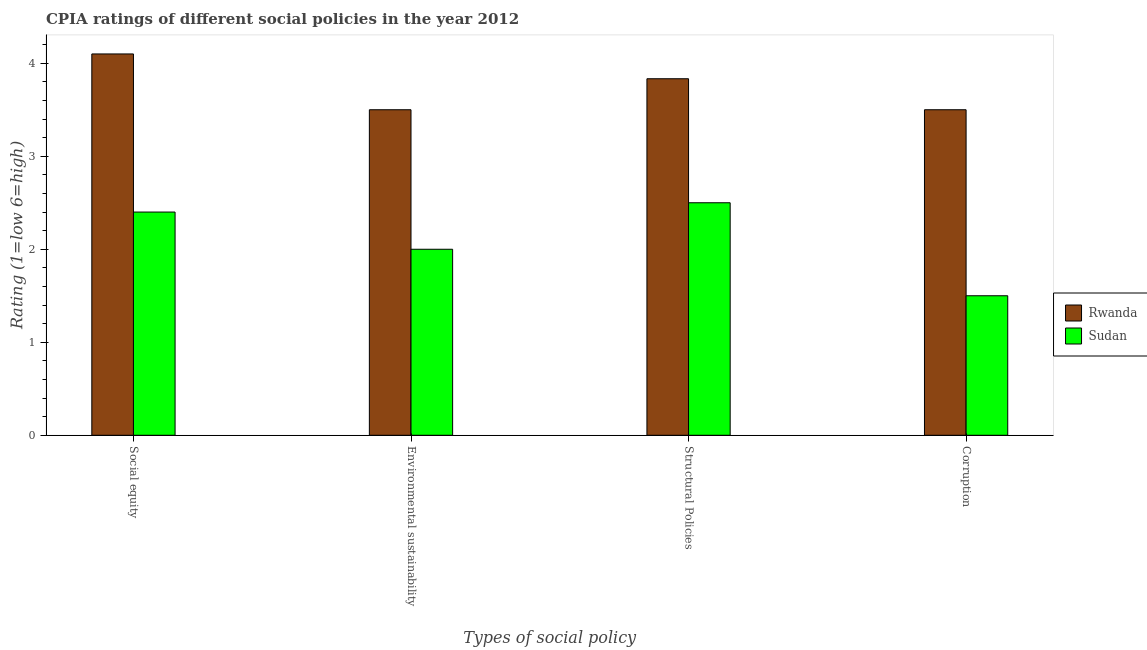How many groups of bars are there?
Offer a terse response. 4. Are the number of bars on each tick of the X-axis equal?
Offer a very short reply. Yes. How many bars are there on the 4th tick from the right?
Keep it short and to the point. 2. What is the label of the 2nd group of bars from the left?
Give a very brief answer. Environmental sustainability. What is the cpia rating of structural policies in Rwanda?
Your response must be concise. 3.83. Across all countries, what is the maximum cpia rating of environmental sustainability?
Offer a terse response. 3.5. In which country was the cpia rating of corruption maximum?
Offer a terse response. Rwanda. In which country was the cpia rating of structural policies minimum?
Offer a terse response. Sudan. What is the total cpia rating of social equity in the graph?
Your response must be concise. 6.5. What is the difference between the cpia rating of corruption in Rwanda and that in Sudan?
Your answer should be compact. 2. What is the average cpia rating of corruption per country?
Provide a succinct answer. 2.5. What is the difference between the cpia rating of social equity and cpia rating of environmental sustainability in Sudan?
Your response must be concise. 0.4. In how many countries, is the cpia rating of environmental sustainability greater than 0.4 ?
Your answer should be compact. 2. What is the ratio of the cpia rating of structural policies in Rwanda to that in Sudan?
Offer a terse response. 1.53. Is the cpia rating of structural policies in Sudan less than that in Rwanda?
Offer a very short reply. Yes. Is the difference between the cpia rating of structural policies in Sudan and Rwanda greater than the difference between the cpia rating of corruption in Sudan and Rwanda?
Offer a very short reply. Yes. What is the difference between the highest and the second highest cpia rating of social equity?
Make the answer very short. 1.7. What is the difference between the highest and the lowest cpia rating of corruption?
Provide a short and direct response. 2. Is the sum of the cpia rating of structural policies in Sudan and Rwanda greater than the maximum cpia rating of social equity across all countries?
Your answer should be very brief. Yes. Is it the case that in every country, the sum of the cpia rating of environmental sustainability and cpia rating of structural policies is greater than the sum of cpia rating of corruption and cpia rating of social equity?
Keep it short and to the point. No. What does the 2nd bar from the left in Environmental sustainability represents?
Give a very brief answer. Sudan. What does the 1st bar from the right in Social equity represents?
Offer a terse response. Sudan. Is it the case that in every country, the sum of the cpia rating of social equity and cpia rating of environmental sustainability is greater than the cpia rating of structural policies?
Offer a very short reply. Yes. How many bars are there?
Offer a very short reply. 8. How many countries are there in the graph?
Offer a very short reply. 2. Are the values on the major ticks of Y-axis written in scientific E-notation?
Offer a terse response. No. Does the graph contain any zero values?
Provide a succinct answer. No. Where does the legend appear in the graph?
Offer a terse response. Center right. How are the legend labels stacked?
Offer a very short reply. Vertical. What is the title of the graph?
Your answer should be very brief. CPIA ratings of different social policies in the year 2012. Does "Montenegro" appear as one of the legend labels in the graph?
Provide a short and direct response. No. What is the label or title of the X-axis?
Your answer should be very brief. Types of social policy. What is the label or title of the Y-axis?
Offer a very short reply. Rating (1=low 6=high). What is the Rating (1=low 6=high) of Rwanda in Environmental sustainability?
Offer a very short reply. 3.5. What is the Rating (1=low 6=high) of Rwanda in Structural Policies?
Offer a very short reply. 3.83. What is the Rating (1=low 6=high) of Sudan in Structural Policies?
Offer a very short reply. 2.5. What is the Rating (1=low 6=high) in Rwanda in Corruption?
Your answer should be compact. 3.5. What is the Rating (1=low 6=high) of Sudan in Corruption?
Your response must be concise. 1.5. Across all Types of social policy, what is the maximum Rating (1=low 6=high) in Sudan?
Provide a succinct answer. 2.5. What is the total Rating (1=low 6=high) in Rwanda in the graph?
Your response must be concise. 14.93. What is the difference between the Rating (1=low 6=high) of Rwanda in Social equity and that in Environmental sustainability?
Keep it short and to the point. 0.6. What is the difference between the Rating (1=low 6=high) of Sudan in Social equity and that in Environmental sustainability?
Keep it short and to the point. 0.4. What is the difference between the Rating (1=low 6=high) of Rwanda in Social equity and that in Structural Policies?
Make the answer very short. 0.27. What is the difference between the Rating (1=low 6=high) in Sudan in Social equity and that in Corruption?
Offer a terse response. 0.9. What is the difference between the Rating (1=low 6=high) of Rwanda in Environmental sustainability and that in Corruption?
Offer a very short reply. 0. What is the difference between the Rating (1=low 6=high) of Rwanda in Social equity and the Rating (1=low 6=high) of Sudan in Environmental sustainability?
Offer a very short reply. 2.1. What is the difference between the Rating (1=low 6=high) in Rwanda in Social equity and the Rating (1=low 6=high) in Sudan in Structural Policies?
Your response must be concise. 1.6. What is the difference between the Rating (1=low 6=high) in Rwanda in Social equity and the Rating (1=low 6=high) in Sudan in Corruption?
Provide a succinct answer. 2.6. What is the difference between the Rating (1=low 6=high) of Rwanda in Environmental sustainability and the Rating (1=low 6=high) of Sudan in Structural Policies?
Your response must be concise. 1. What is the difference between the Rating (1=low 6=high) of Rwanda in Environmental sustainability and the Rating (1=low 6=high) of Sudan in Corruption?
Offer a terse response. 2. What is the difference between the Rating (1=low 6=high) of Rwanda in Structural Policies and the Rating (1=low 6=high) of Sudan in Corruption?
Make the answer very short. 2.33. What is the average Rating (1=low 6=high) in Rwanda per Types of social policy?
Keep it short and to the point. 3.73. What is the difference between the Rating (1=low 6=high) in Rwanda and Rating (1=low 6=high) in Sudan in Environmental sustainability?
Ensure brevity in your answer.  1.5. What is the difference between the Rating (1=low 6=high) of Rwanda and Rating (1=low 6=high) of Sudan in Structural Policies?
Your response must be concise. 1.33. What is the ratio of the Rating (1=low 6=high) in Rwanda in Social equity to that in Environmental sustainability?
Make the answer very short. 1.17. What is the ratio of the Rating (1=low 6=high) of Rwanda in Social equity to that in Structural Policies?
Make the answer very short. 1.07. What is the ratio of the Rating (1=low 6=high) in Rwanda in Social equity to that in Corruption?
Your response must be concise. 1.17. What is the ratio of the Rating (1=low 6=high) in Sudan in Social equity to that in Corruption?
Give a very brief answer. 1.6. What is the ratio of the Rating (1=low 6=high) in Sudan in Environmental sustainability to that in Structural Policies?
Ensure brevity in your answer.  0.8. What is the ratio of the Rating (1=low 6=high) of Rwanda in Environmental sustainability to that in Corruption?
Offer a terse response. 1. What is the ratio of the Rating (1=low 6=high) of Sudan in Environmental sustainability to that in Corruption?
Provide a succinct answer. 1.33. What is the ratio of the Rating (1=low 6=high) in Rwanda in Structural Policies to that in Corruption?
Offer a very short reply. 1.1. What is the difference between the highest and the second highest Rating (1=low 6=high) in Rwanda?
Your answer should be very brief. 0.27. What is the difference between the highest and the second highest Rating (1=low 6=high) of Sudan?
Your answer should be compact. 0.1. What is the difference between the highest and the lowest Rating (1=low 6=high) of Rwanda?
Offer a very short reply. 0.6. 